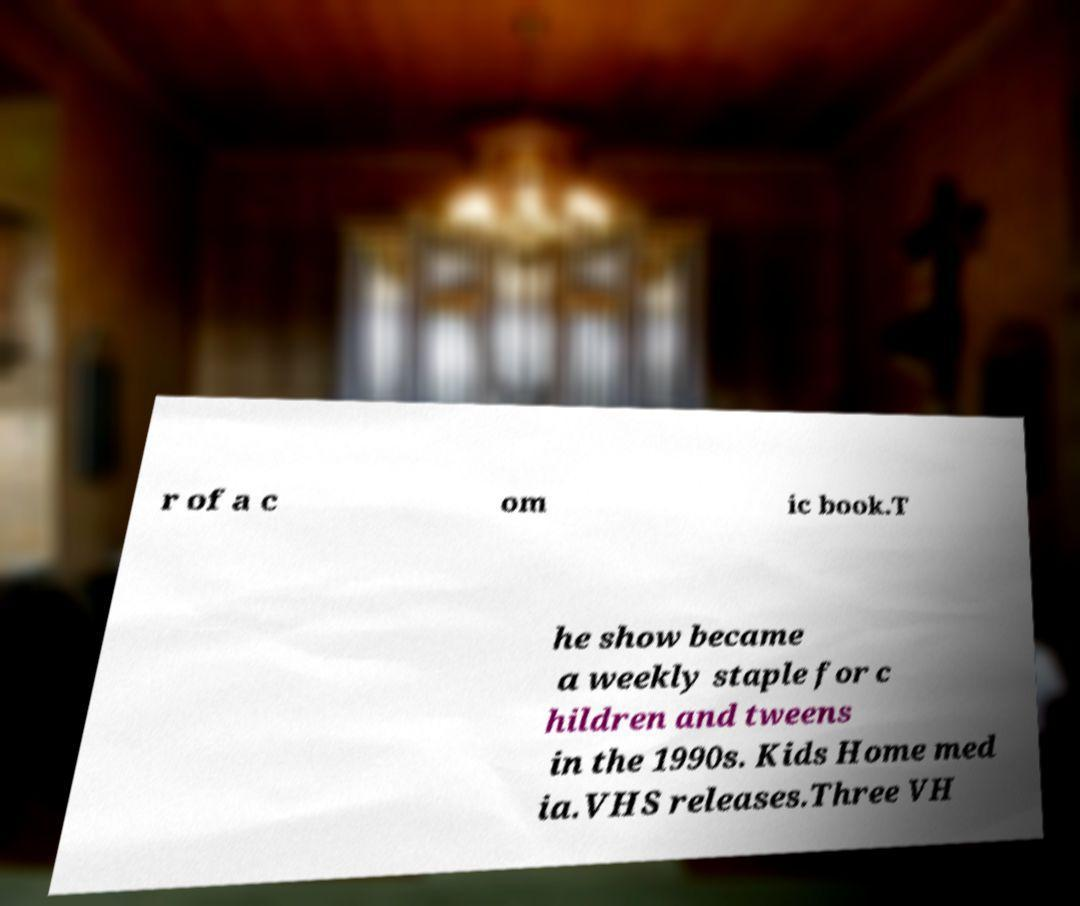Please read and relay the text visible in this image. What does it say? r of a c om ic book.T he show became a weekly staple for c hildren and tweens in the 1990s. Kids Home med ia.VHS releases.Three VH 